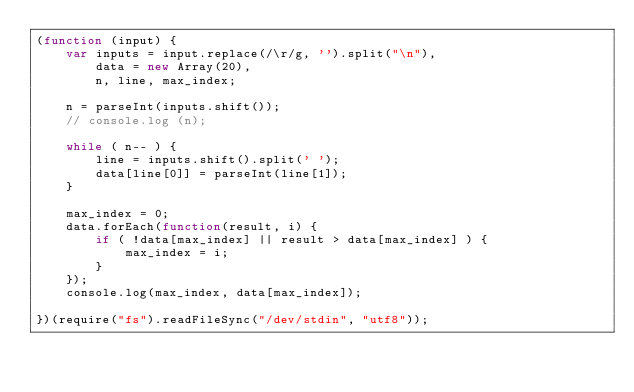Convert code to text. <code><loc_0><loc_0><loc_500><loc_500><_JavaScript_>(function (input) {
    var inputs = input.replace(/\r/g, '').split("\n"),
        data = new Array(20),
        n, line, max_index;

    n = parseInt(inputs.shift());
    // console.log (n);

    while ( n-- ) {
        line = inputs.shift().split(' ');
        data[line[0]] = parseInt(line[1]);
    }

    max_index = 0;
    data.forEach(function(result, i) {
        if ( !data[max_index] || result > data[max_index] ) {
            max_index = i;
        }
    });
    console.log(max_index, data[max_index]);

})(require("fs").readFileSync("/dev/stdin", "utf8"));</code> 